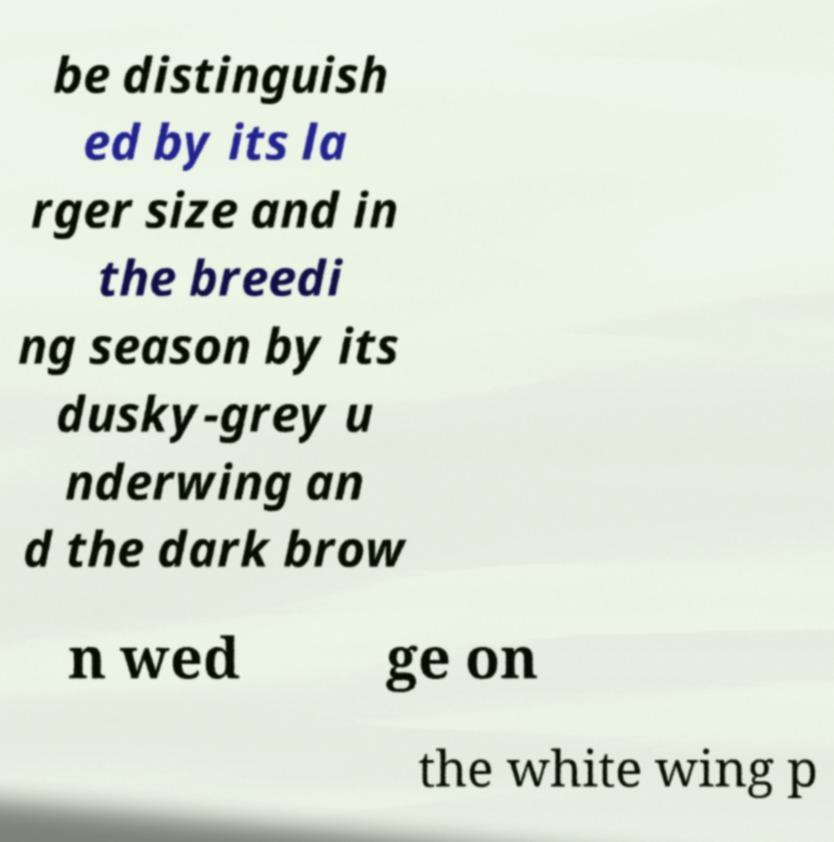Can you accurately transcribe the text from the provided image for me? be distinguish ed by its la rger size and in the breedi ng season by its dusky-grey u nderwing an d the dark brow n wed ge on the white wing p 